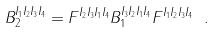<formula> <loc_0><loc_0><loc_500><loc_500>B _ { 2 } ^ { I _ { 1 } I _ { 2 } I _ { 3 } I _ { 4 } } = F ^ { I _ { 2 } I _ { 3 } I _ { 1 } I _ { 4 } } B _ { 1 } ^ { I _ { 3 } I _ { 2 } I _ { 1 } I _ { 4 } } F ^ { I _ { 1 } I _ { 2 } I _ { 3 } I _ { 4 } } \ .</formula> 